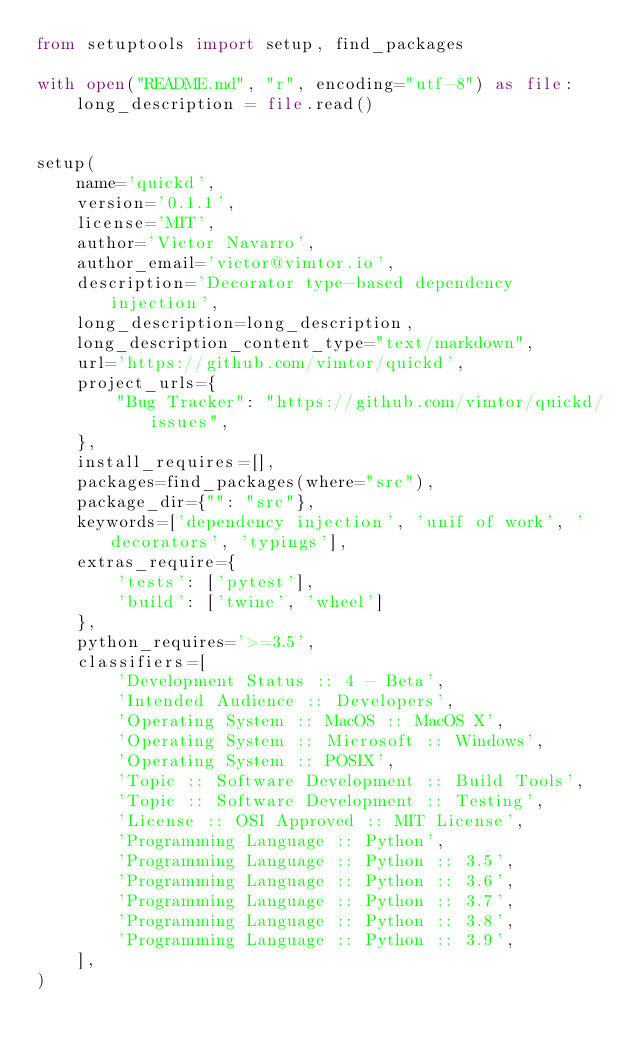<code> <loc_0><loc_0><loc_500><loc_500><_Python_>from setuptools import setup, find_packages

with open("README.md", "r", encoding="utf-8") as file:
    long_description = file.read()


setup(
    name='quickd',
    version='0.1.1',
    license='MIT',
    author='Victor Navarro',
    author_email='victor@vimtor.io',
    description='Decorator type-based dependency injection',
    long_description=long_description,
    long_description_content_type="text/markdown",
    url='https://github.com/vimtor/quickd',
    project_urls={
        "Bug Tracker": "https://github.com/vimtor/quickd/issues",
    },
    install_requires=[],
    packages=find_packages(where="src"),
    package_dir={"": "src"},
    keywords=['dependency injection', 'unif of work', 'decorators', 'typings'],
    extras_require={
        'tests': ['pytest'],
        'build': ['twine', 'wheel']
    },
    python_requires='>=3.5',
    classifiers=[
        'Development Status :: 4 - Beta',
        'Intended Audience :: Developers',
        'Operating System :: MacOS :: MacOS X',
        'Operating System :: Microsoft :: Windows',
        'Operating System :: POSIX',
        'Topic :: Software Development :: Build Tools',
        'Topic :: Software Development :: Testing',
        'License :: OSI Approved :: MIT License',
        'Programming Language :: Python',
        'Programming Language :: Python :: 3.5',
        'Programming Language :: Python :: 3.6',
        'Programming Language :: Python :: 3.7',
        'Programming Language :: Python :: 3.8',
        'Programming Language :: Python :: 3.9',
    ],
)
</code> 